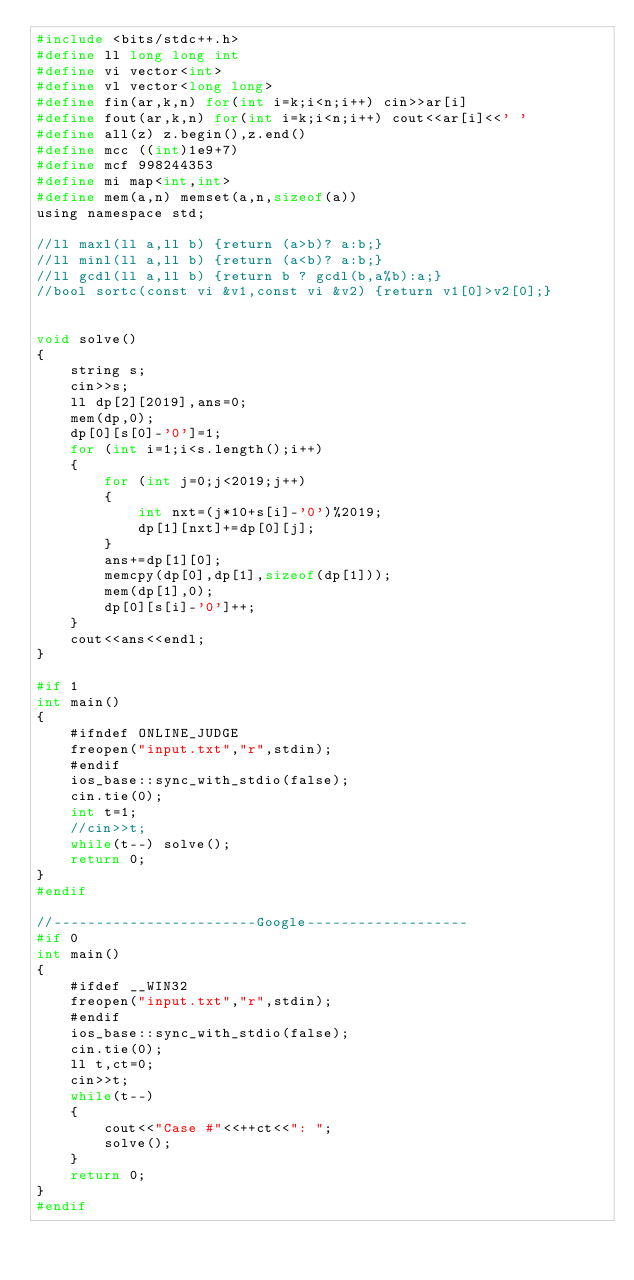Convert code to text. <code><loc_0><loc_0><loc_500><loc_500><_C_>#include <bits/stdc++.h>
#define ll long long int
#define vi vector<int>
#define vl vector<long long>
#define fin(ar,k,n) for(int i=k;i<n;i++) cin>>ar[i]
#define fout(ar,k,n) for(int i=k;i<n;i++) cout<<ar[i]<<' '
#define all(z) z.begin(),z.end()
#define mcc ((int)1e9+7)
#define mcf 998244353
#define mi map<int,int>
#define mem(a,n) memset(a,n,sizeof(a))
using namespace std;

//ll maxl(ll a,ll b) {return (a>b)? a:b;}
//ll minl(ll a,ll b) {return (a<b)? a:b;}
//ll gcdl(ll a,ll b) {return b ? gcdl(b,a%b):a;}
//bool sortc(const vi &v1,const vi &v2) {return v1[0]>v2[0];}


void solve()
{
    string s;
    cin>>s;
    ll dp[2][2019],ans=0;
    mem(dp,0);
    dp[0][s[0]-'0']=1;
    for (int i=1;i<s.length();i++)
    {
        for (int j=0;j<2019;j++)
        {
            int nxt=(j*10+s[i]-'0')%2019;
            dp[1][nxt]+=dp[0][j];
        }
        ans+=dp[1][0];
        memcpy(dp[0],dp[1],sizeof(dp[1]));
        mem(dp[1],0);
        dp[0][s[i]-'0']++;
    }
    cout<<ans<<endl;
}

#if 1
int main()
{
    #ifndef ONLINE_JUDGE
    freopen("input.txt","r",stdin);
    #endif
    ios_base::sync_with_stdio(false);
    cin.tie(0);
    int t=1;
    //cin>>t;
    while(t--) solve();
    return 0;
}
#endif

//------------------------Google-------------------
#if 0
int main()
{
    #ifdef __WIN32
    freopen("input.txt","r",stdin);
    #endif
    ios_base::sync_with_stdio(false);
    cin.tie(0);
    ll t,ct=0;
    cin>>t;
    while(t--)
    {
        cout<<"Case #"<<++ct<<": ";
        solve();
    }
    return 0;
}
#endif
</code> 